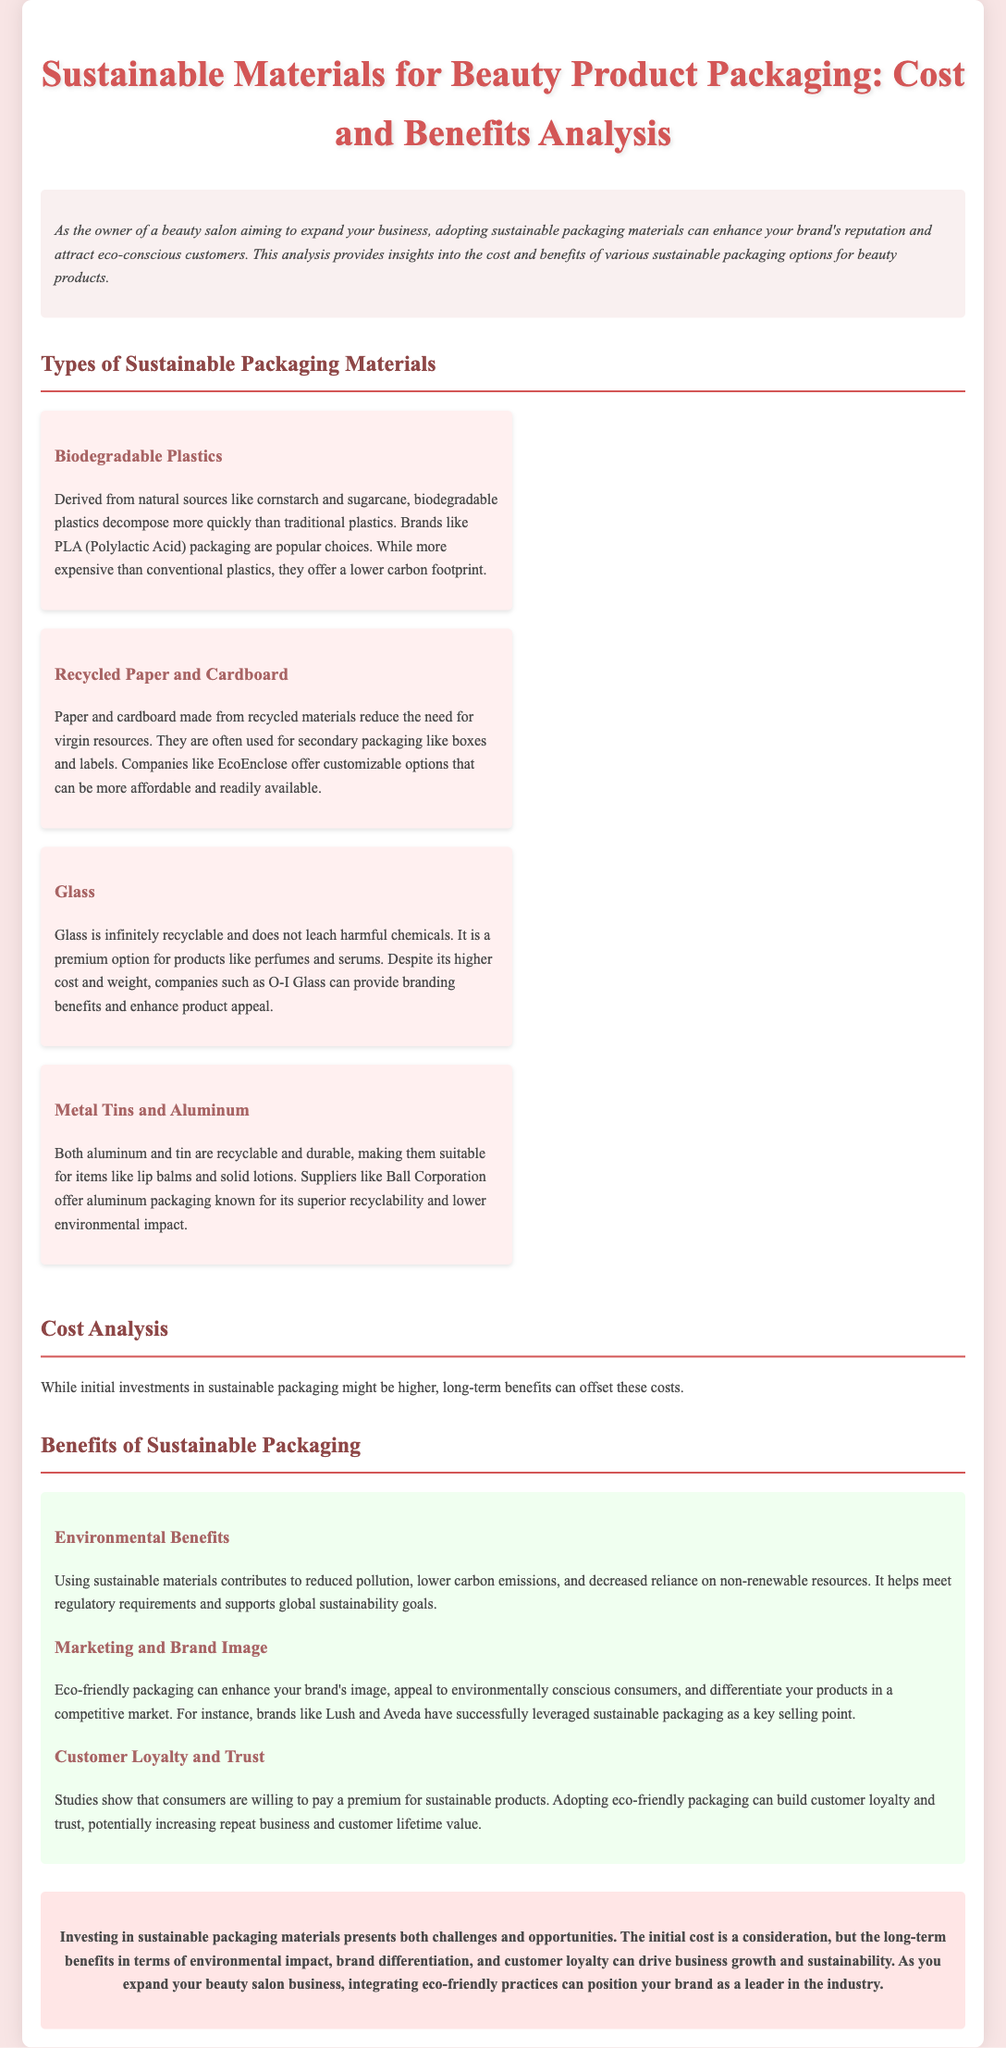what are biodegradable plastics derived from? Biodegradable plastics are derived from natural sources like cornstarch and sugarcane.
Answer: cornstarch and sugarcane which company offers customizable recycled paper options? EcoEnclose is mentioned as a company that offers customizable options for recycled paper.
Answer: EcoEnclose what is a key benefit of using glass for packaging? Glass is infinitely recyclable and does not leach harmful chemicals.
Answer: infinitely recyclable which packaging material is suitable for lip balms? The document states that both aluminum and tin are suitable for lip balms.
Answer: aluminum and tin how do sustainable materials contribute to environmental benefits? Using sustainable materials contributes to reduced pollution and lower carbon emissions.
Answer: reduced pollution and lower carbon emissions what is a consequence of adopting eco-friendly packaging for customer loyalty? Adopting eco-friendly packaging can build customer loyalty and trust.
Answer: build customer loyalty and trust how might sustainable packaging impact brand image? Eco-friendly packaging can enhance your brand's image and differentiate your products.
Answer: enhance brand's image what does the conclusion suggest about the investment in sustainable packaging? The conclusion suggests that the long-term benefits can drive business growth and sustainability.
Answer: drive business growth and sustainability 